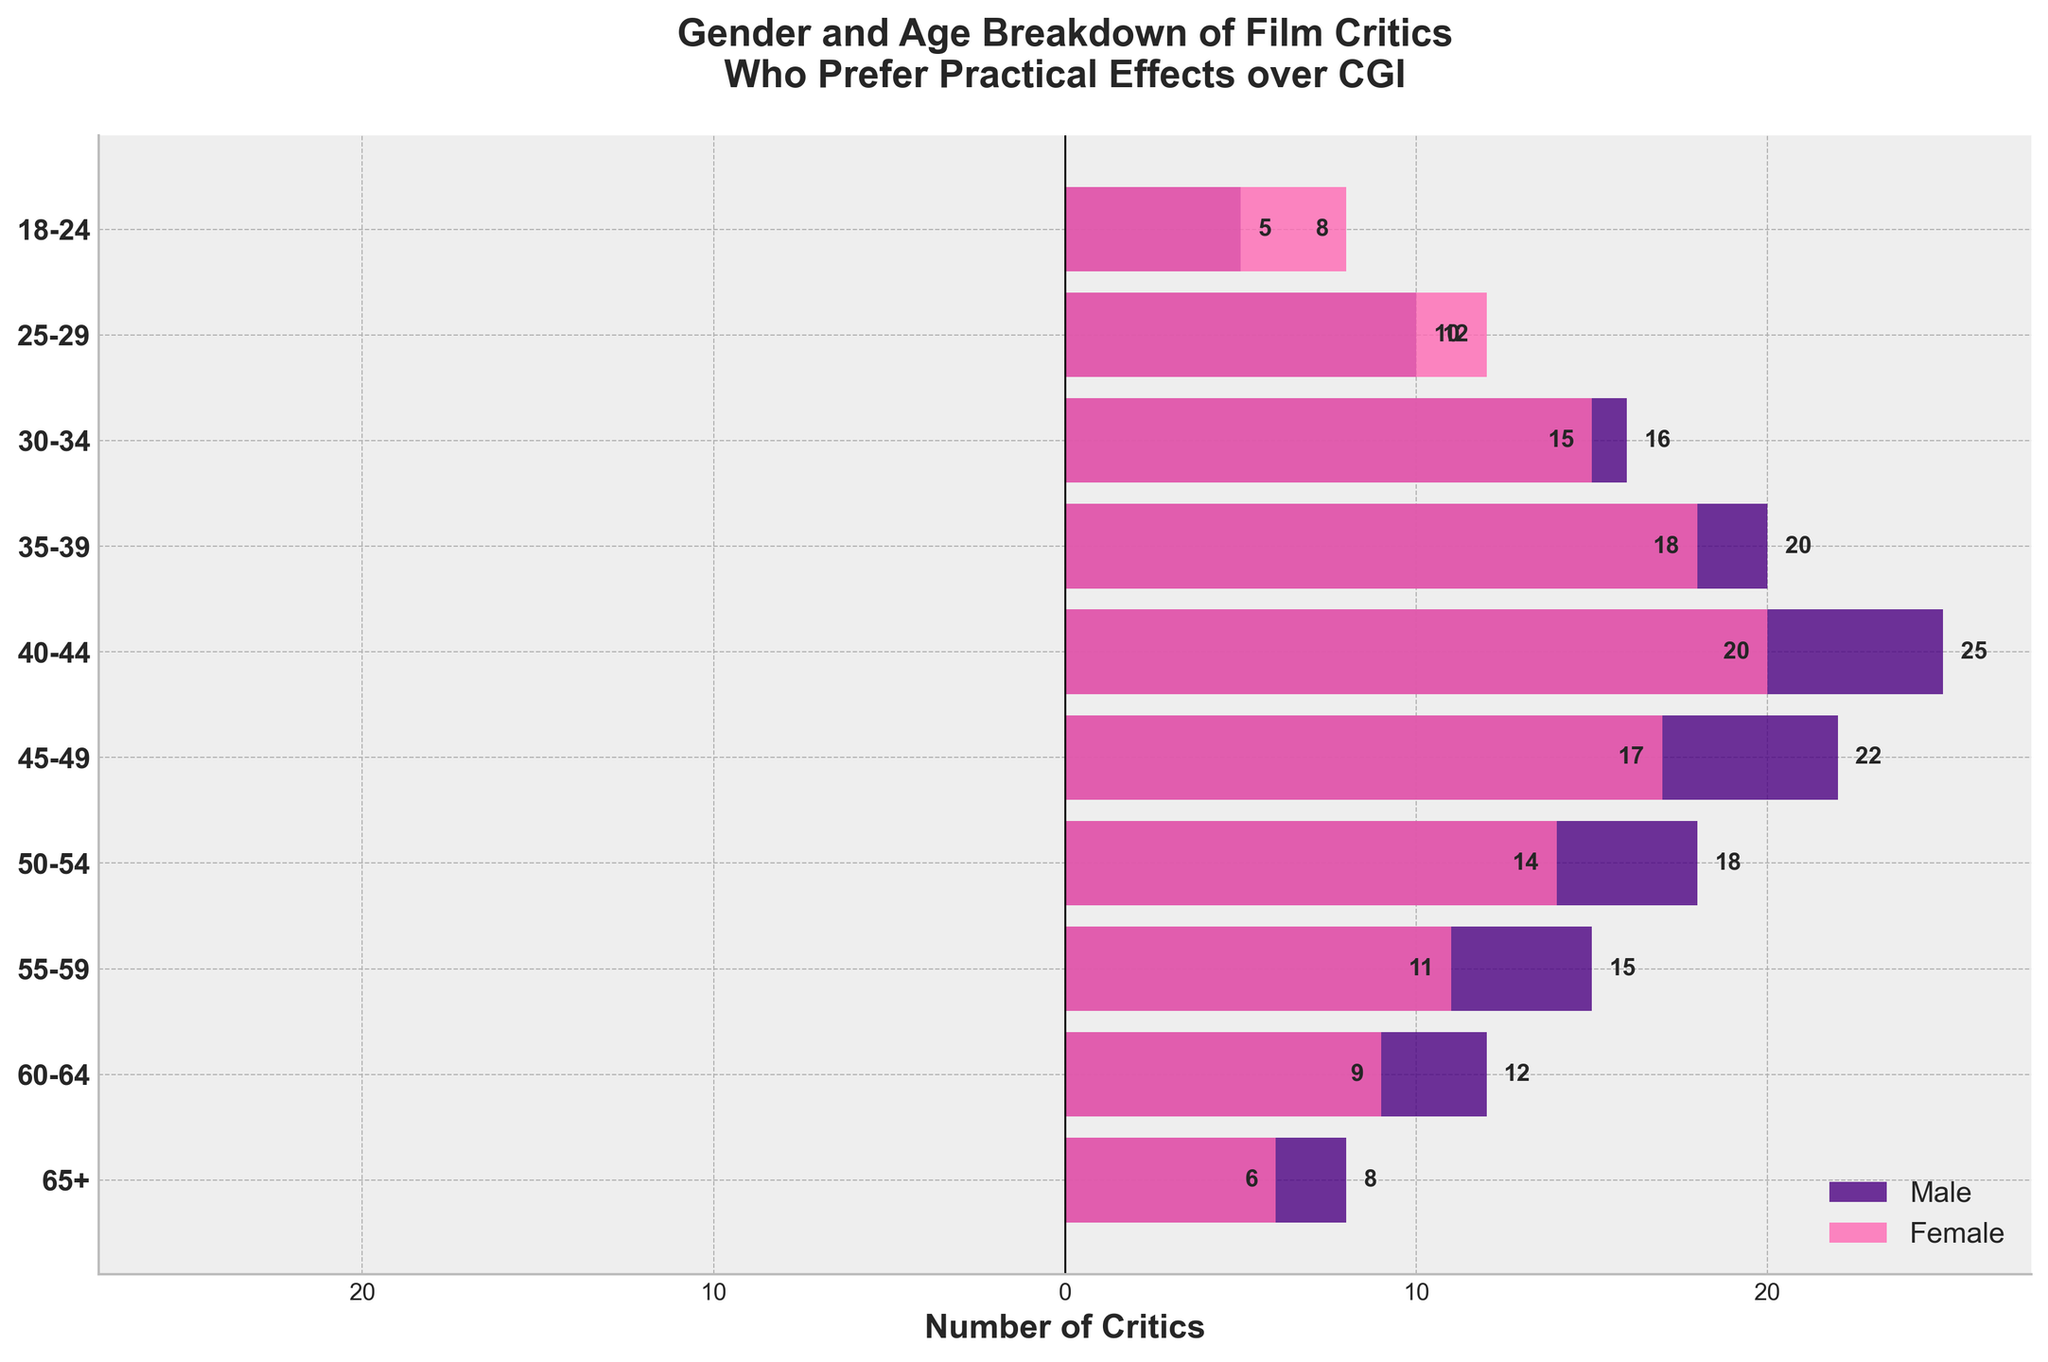What's the title of the figure? The title of a figure is usually written at the top and provides a brief summary of what the graph is about. In this case, the figure's title is located at the top center and reads: "Gender and Age Breakdown of Film Critics Who Prefer Practical Effects over CGI."
Answer: Gender and Age Breakdown of Film Critics Who Prefer Practical Effects over CGI What do the bars represent in the figure? The bars in a population pyramid represent the number of individuals in each age group, separated by gender. The right-hand side represents females and the left-hand side represents males. The length of each bar corresponds to the number of critics in each age group.
Answer: Number of critics in each age group by gender What is the axis label on the x-axis? The axis label on the x-axis provides information about what is being measured along the horizontal axis. In this case, it reads: "Number of Critics."
Answer: Number of Critics Which age group has the highest number of male film critics who prefer practical effects over CGI? To find the age group with the highest number of male critics, look for the longest bar on the left side of the population pyramid. The age group "40-44" has the longest bar, indicating the highest number of male critics.
Answer: 40-44 How many female film critics prefer practical effects over CGI in the 50-54 age group? Look at the bar corresponding to the 50-54 age group on the right side of the pyramid (female side). The bar extends to -14, indicating there are 14 female critics in this age group.
Answer: 14 How many more male critics are there compared to female critics in the 25-29 age group? The number of male critics in the 25-29 age group is 10, and the number of female critics is 12. The difference is calculated as 10 - 12 = -2, so there are 2 more female critics than male critics in this age group.
Answer: -2 Which gender is more dominant in the 60-64 age group? Compare the bars on both sides for the 60-64 age group. The male side extends to 12 and the female side extends to -9. Since 12 is greater than 9, males are more dominant in this age group.
Answer: Male How many total film critics are in the 18-24 age group? Add the number of male critics (5) and female critics (8) in the 18-24 age group to get the total number of critics. 5 + 8 = 13.
Answer: 13 What is the average number of male critics across all age groups? Add the number of male critics in all age groups and divide by the number of age groups. The numbers are 8, 12, 15, 18, 22, 25, 20, 16, 10, and 5. Sum = 151. There are 10 age groups, so the average is 151 / 10 = 15.1.
Answer: 15.1 